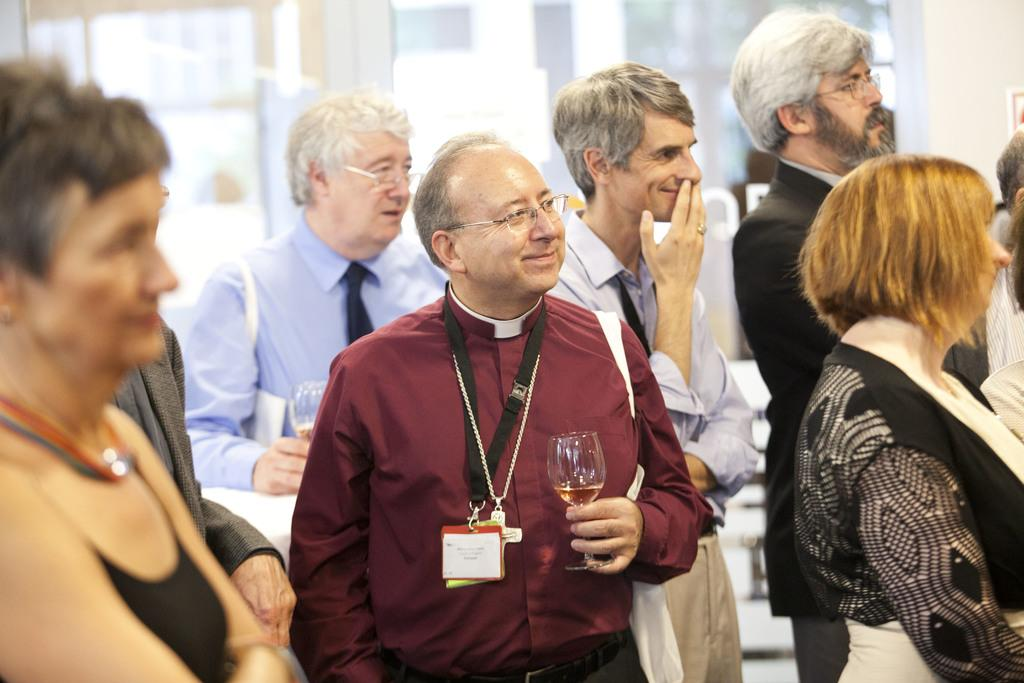What are the people in the image doing? The people in the image are standing. What objects are some of the people holding? Some of the people are holding glasses. What can be seen in the background of the image? There is a wall in the background of the image. What type of bushes can be seen growing near the wall in the image? There are no bushes visible in the image; only the wall is present in the background. 